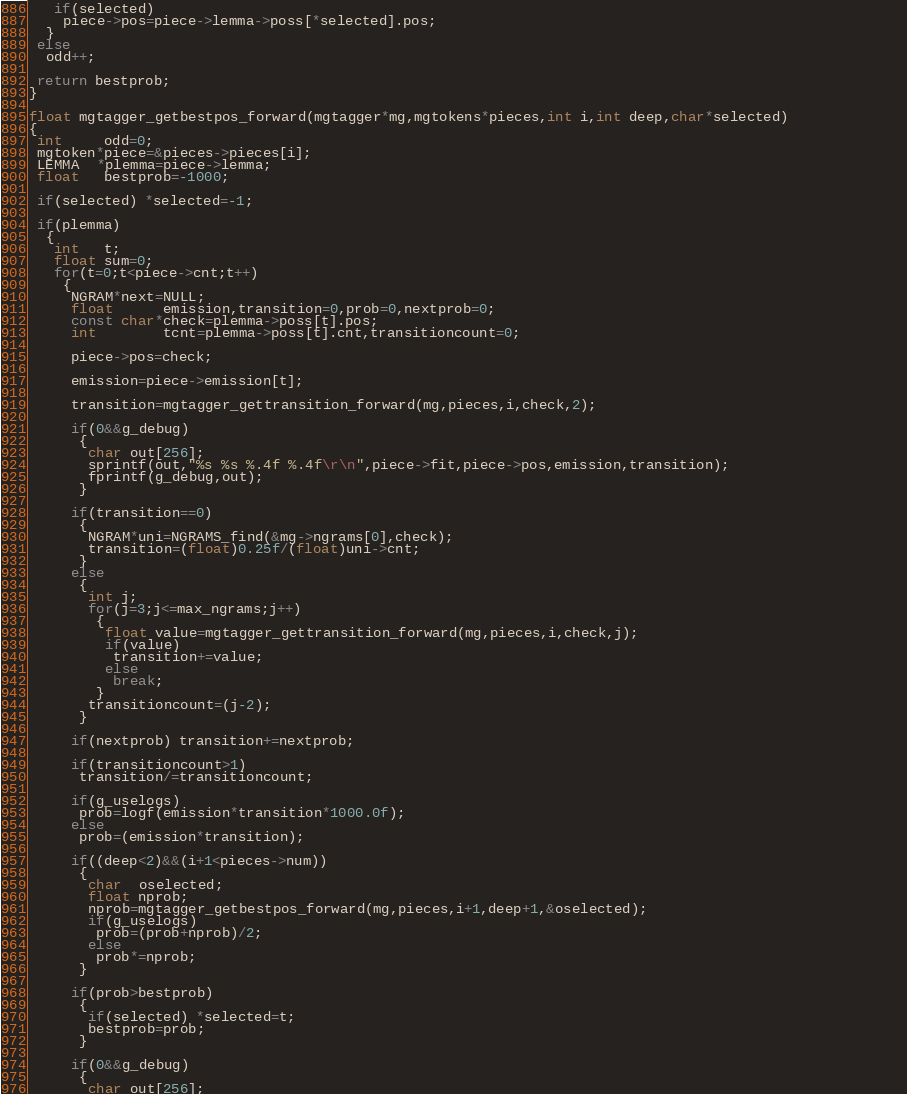Convert code to text. <code><loc_0><loc_0><loc_500><loc_500><_C_>   if(selected)
    piece->pos=piece->lemma->poss[*selected].pos;      
  } 
 else
  odd++; 

 return bestprob; 
}

float mgtagger_getbestpos_forward(mgtagger*mg,mgtokens*pieces,int i,int deep,char*selected)
{
 int     odd=0;
 mgtoken*piece=&pieces->pieces[i];
 LEMMA  *plemma=piece->lemma;   
 float   bestprob=-1000;
 
 if(selected) *selected=-1; 
 
 if(plemma)
  {
   int   t;
   float sum=0;
   for(t=0;t<piece->cnt;t++)
    {
     NGRAM*next=NULL;
     float      emission,transition=0,prob=0,nextprob=0;
     const char*check=plemma->poss[t].pos;
     int        tcnt=plemma->poss[t].cnt,transitioncount=0;
     
     piece->pos=check;
     
     emission=piece->emission[t];  
          
     transition=mgtagger_gettransition_forward(mg,pieces,i,check,2); 
     
     if(0&&g_debug)
      {
       char out[256];
       sprintf(out,"%s %s %.4f %.4f\r\n",piece->fit,piece->pos,emission,transition);                     
       fprintf(g_debug,out);                     
      } 
     
     if(transition==0)
      {
       NGRAM*uni=NGRAMS_find(&mg->ngrams[0],check);
       transition=(float)0.25f/(float)uni->cnt;
      }
     else       
      {
       int j;
       for(j=3;j<=max_ngrams;j++)
        {
         float value=mgtagger_gettransition_forward(mg,pieces,i,check,j); 
         if(value)
          transition+=value;
         else
          break; 
        }
       transitioncount=(j-2); 
      } 
                                                
     if(nextprob) transition+=nextprob;  
          
     if(transitioncount>1)
      transition/=transitioncount;        
     
     if(g_uselogs)
      prob=logf(emission*transition*1000.0f);        
     else
      prob=(emission*transition);        
     
     if((deep<2)&&(i+1<pieces->num))
      {
       char  oselected;
       float nprob;       
       nprob=mgtagger_getbestpos_forward(mg,pieces,i+1,deep+1,&oselected);
       if(g_uselogs)
        prob=(prob+nprob)/2;
       else
        prob*=nprob;
      }                      
     
     if(prob>bestprob)  
      {
       if(selected) *selected=t;
       bestprob=prob;
      }              
     
     if(0&&g_debug)
      {
       char out[256];</code> 